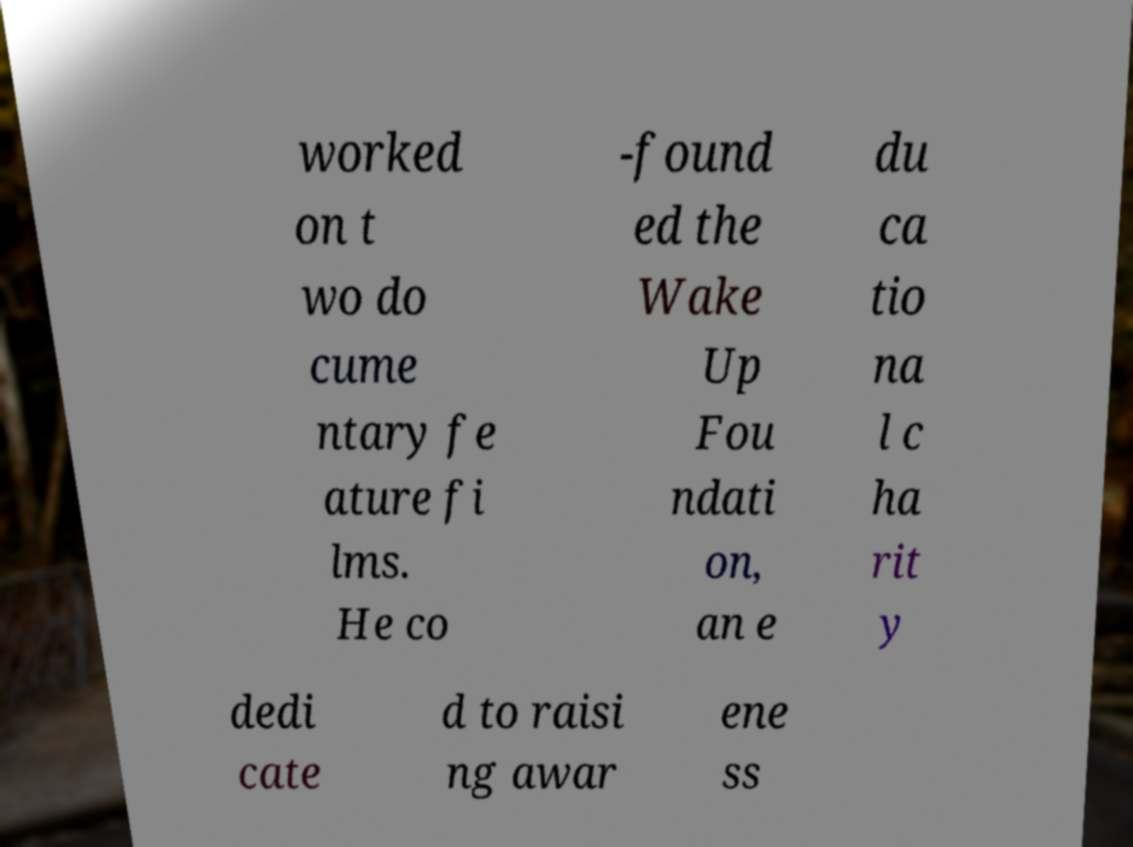Please identify and transcribe the text found in this image. worked on t wo do cume ntary fe ature fi lms. He co -found ed the Wake Up Fou ndati on, an e du ca tio na l c ha rit y dedi cate d to raisi ng awar ene ss 